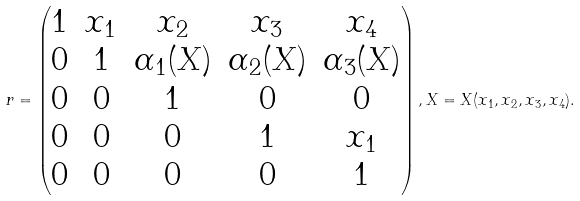Convert formula to latex. <formula><loc_0><loc_0><loc_500><loc_500>r = \begin{pmatrix} 1 & x _ { 1 } & x _ { 2 } & x _ { 3 } & x _ { 4 } \\ 0 & 1 & \alpha _ { 1 } ( X ) & \alpha _ { 2 } ( X ) & \alpha _ { 3 } ( X ) \\ 0 & 0 & 1 & 0 & 0 \\ 0 & 0 & 0 & 1 & x _ { 1 } \\ 0 & 0 & 0 & 0 & 1 \end{pmatrix} , X = X ( x _ { 1 } , x _ { 2 } , x _ { 3 } , x _ { 4 } ) .</formula> 